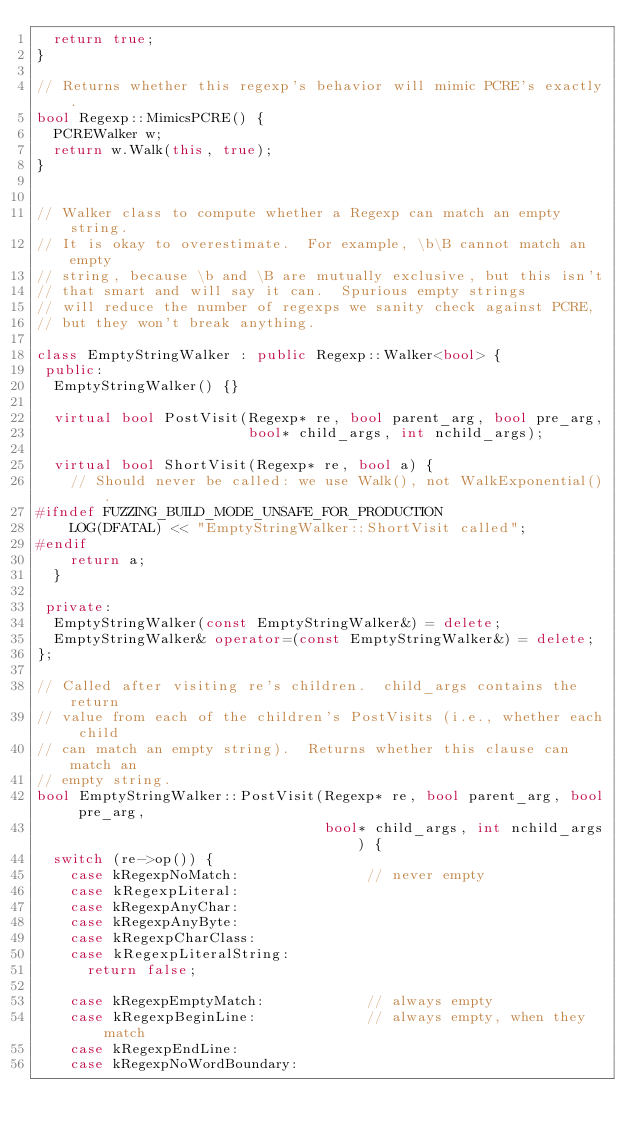Convert code to text. <code><loc_0><loc_0><loc_500><loc_500><_C++_>  return true;
}

// Returns whether this regexp's behavior will mimic PCRE's exactly.
bool Regexp::MimicsPCRE() {
  PCREWalker w;
  return w.Walk(this, true);
}


// Walker class to compute whether a Regexp can match an empty string.
// It is okay to overestimate.  For example, \b\B cannot match an empty
// string, because \b and \B are mutually exclusive, but this isn't
// that smart and will say it can.  Spurious empty strings
// will reduce the number of regexps we sanity check against PCRE,
// but they won't break anything.

class EmptyStringWalker : public Regexp::Walker<bool> {
 public:
  EmptyStringWalker() {}

  virtual bool PostVisit(Regexp* re, bool parent_arg, bool pre_arg,
                         bool* child_args, int nchild_args);

  virtual bool ShortVisit(Regexp* re, bool a) {
    // Should never be called: we use Walk(), not WalkExponential().
#ifndef FUZZING_BUILD_MODE_UNSAFE_FOR_PRODUCTION
    LOG(DFATAL) << "EmptyStringWalker::ShortVisit called";
#endif
    return a;
  }

 private:
  EmptyStringWalker(const EmptyStringWalker&) = delete;
  EmptyStringWalker& operator=(const EmptyStringWalker&) = delete;
};

// Called after visiting re's children.  child_args contains the return
// value from each of the children's PostVisits (i.e., whether each child
// can match an empty string).  Returns whether this clause can match an
// empty string.
bool EmptyStringWalker::PostVisit(Regexp* re, bool parent_arg, bool pre_arg,
                                  bool* child_args, int nchild_args) {
  switch (re->op()) {
    case kRegexpNoMatch:               // never empty
    case kRegexpLiteral:
    case kRegexpAnyChar:
    case kRegexpAnyByte:
    case kRegexpCharClass:
    case kRegexpLiteralString:
      return false;

    case kRegexpEmptyMatch:            // always empty
    case kRegexpBeginLine:             // always empty, when they match
    case kRegexpEndLine:
    case kRegexpNoWordBoundary:</code> 